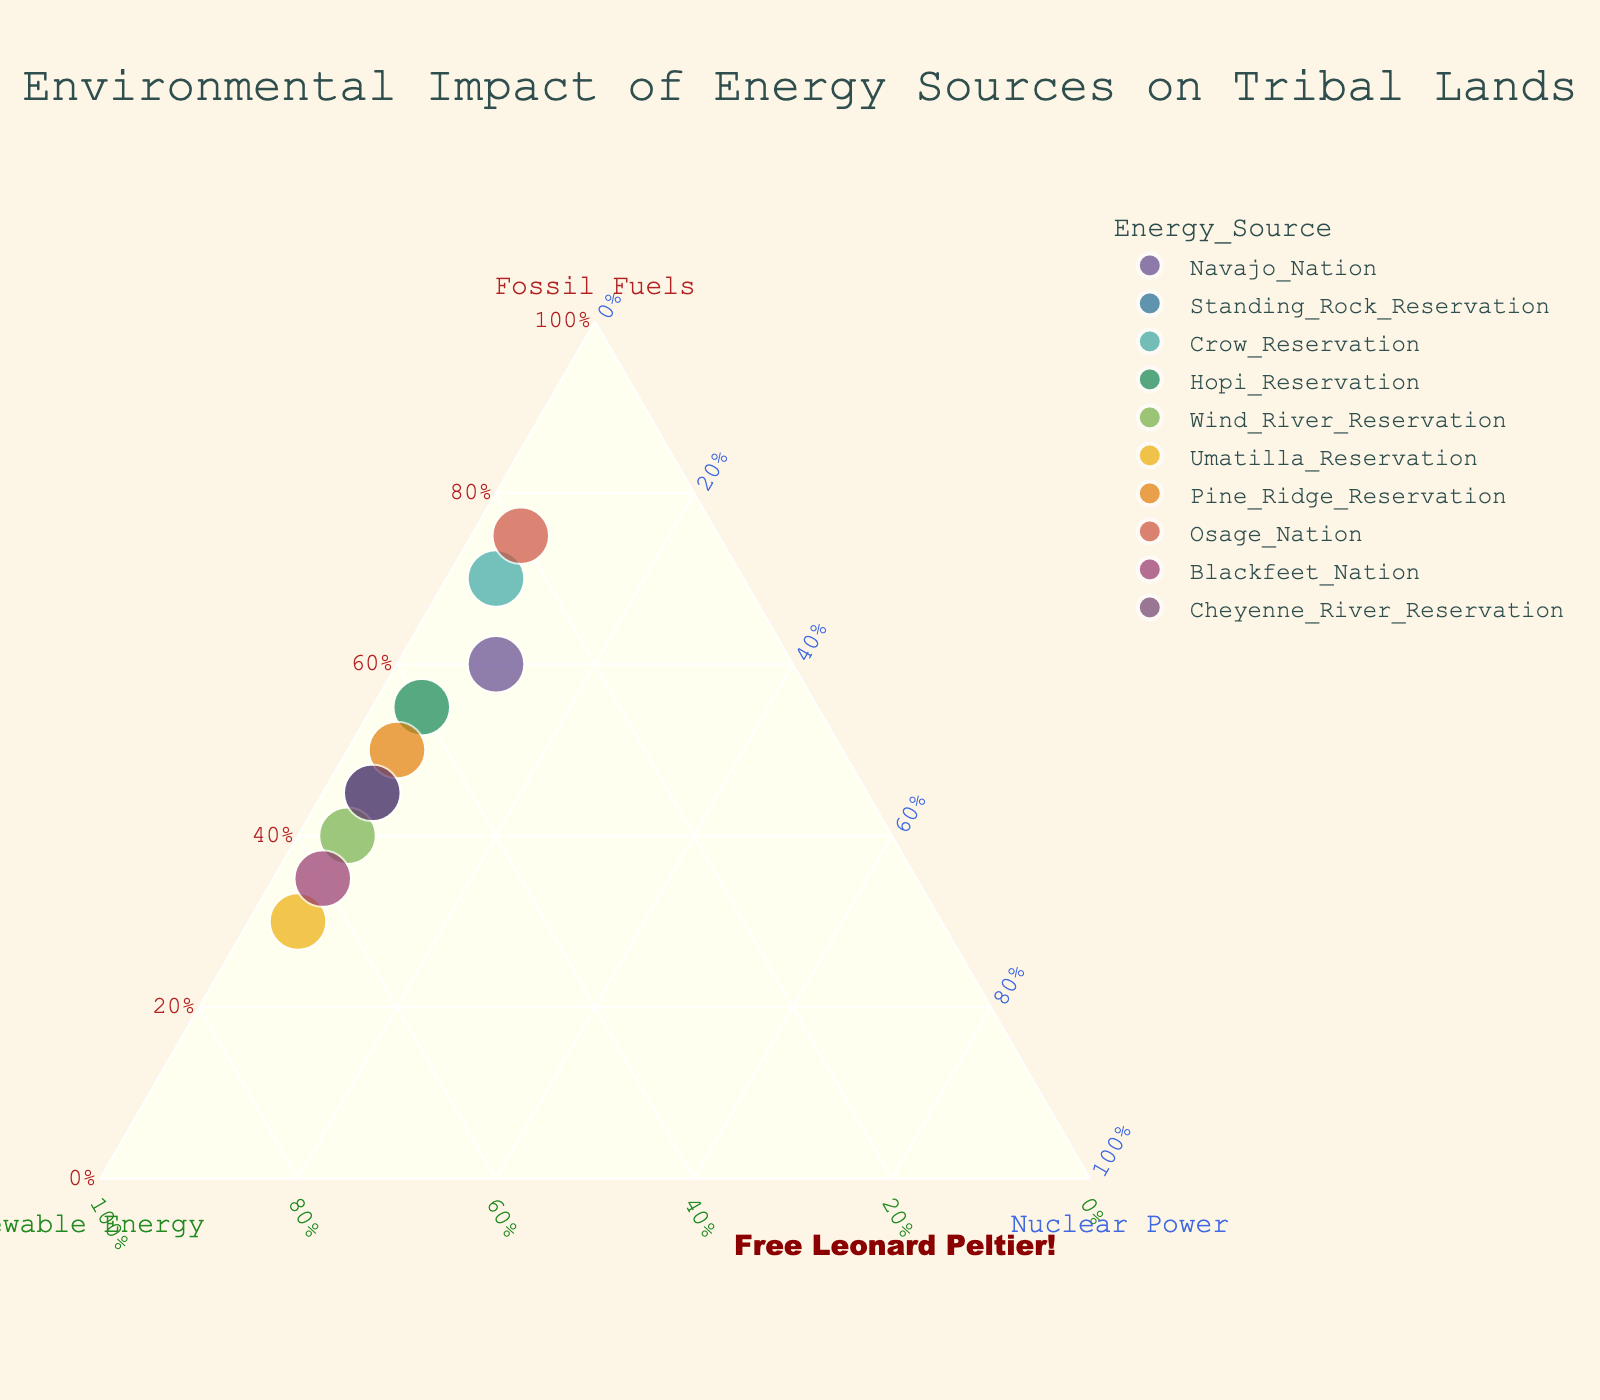How many data points (tribal lands) are represented in the plot? Count the number of unique points (tribal lands) displayed in the plot. There are 10 data points represented by 10 tribal lands in the figure.
Answer: 10 Which energy source is dominantly used by Hopi Reservation? Look at the position of Hopi Reservation on the ternary plot. It is closest to Renewable Energy.
Answer: Renewable Energy What percentage of energy on Wind River Reservation comes from renewable sources? Check the position of Wind River Reservation on the plot and find its percentage on the Renewable Energy axis. The point is located at the 55% Renewable Energy mark.
Answer: 55% Does Blackfeet Nation rely more on fossil fuels or renewable energy? Compare the positions along the Fossil Fuels and Renewable Energy axes for Blackfeet Nation. The point is closer to Renewable Energy at 60% compared to 35% Fossil Fuels.
Answer: Renewable Energy Which reservation has the highest reliance on fossil fuels? Identify the point that is closest to the Fossil Fuels axis. Osage Nation is nearest to this axis at 75%.
Answer: Osage Nation How many reservations have over 50% reliance on renewable energy? Count the number of points where the position along the Renewable Energy axis is more than 50%. Wind River, Umatilla, and Blackfeet Reservations each have over 50%.
Answer: 3 Compare the usage of nuclear power between Standing Rock Reservation and Pine Ridge Reservation. Check the positions of both reservations on the Nuclear Power axis. Both are positioned at 5% nuclear power usage.
Answer: Equal (5%) What's the sum of the fossil fuel percentage used by Crow and Navajo Nation? Sum the fossil fuel percentages of Crow Reservation (70%) and Navajo Nation (60%). The sum is 70% + 60% = 130%.
Answer: 130% If the percentages of fossil fuels and nuclear power were hypothetically swapped for Standing Rock Reservation, what would be the new position on the ternary plot? Currently, Standing Rock has 45% Fossil Fuels and 5% Nuclear Power. If swapped, it would have 5% Fossil Fuels and 45% Nuclear Power. Normalize these values with renewable energy still at 50%: (5, 50, 45). The new ternary position would shift heavily towards Nuclear Power.
Answer: (5%, 50%, 45%) 